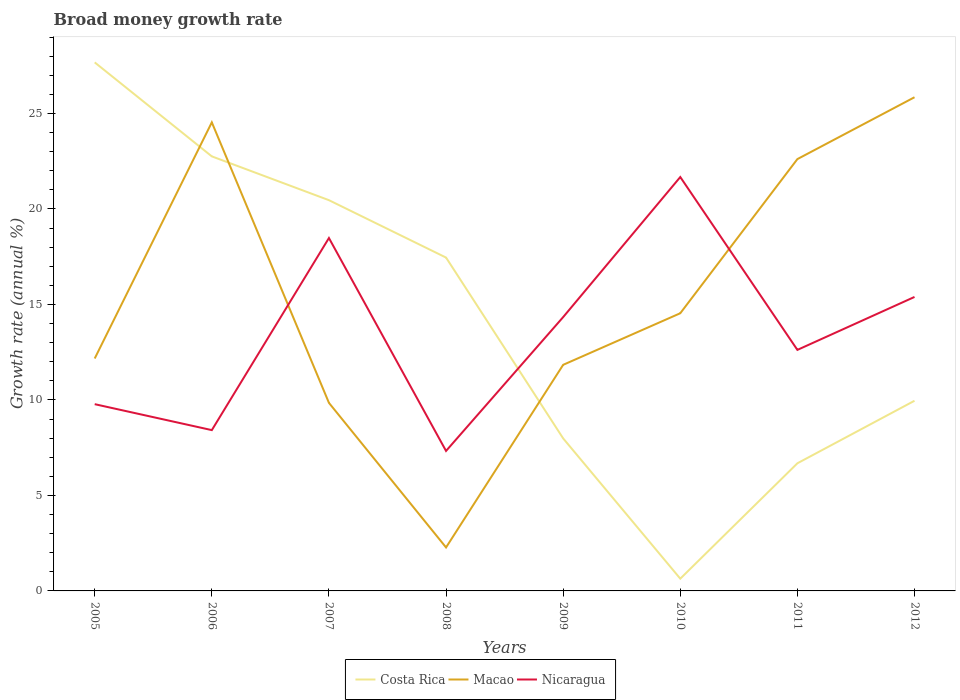How many different coloured lines are there?
Your answer should be compact. 3. Does the line corresponding to Nicaragua intersect with the line corresponding to Costa Rica?
Your answer should be very brief. Yes. Is the number of lines equal to the number of legend labels?
Keep it short and to the point. Yes. Across all years, what is the maximum growth rate in Macao?
Make the answer very short. 2.28. What is the total growth rate in Nicaragua in the graph?
Keep it short and to the point. -8.06. What is the difference between the highest and the second highest growth rate in Nicaragua?
Offer a terse response. 14.34. What is the difference between the highest and the lowest growth rate in Nicaragua?
Ensure brevity in your answer.  4. Is the growth rate in Macao strictly greater than the growth rate in Costa Rica over the years?
Your response must be concise. No. How many years are there in the graph?
Give a very brief answer. 8. What is the difference between two consecutive major ticks on the Y-axis?
Provide a short and direct response. 5. Are the values on the major ticks of Y-axis written in scientific E-notation?
Give a very brief answer. No. Where does the legend appear in the graph?
Your answer should be compact. Bottom center. What is the title of the graph?
Give a very brief answer. Broad money growth rate. Does "Belgium" appear as one of the legend labels in the graph?
Keep it short and to the point. No. What is the label or title of the Y-axis?
Offer a terse response. Growth rate (annual %). What is the Growth rate (annual %) of Costa Rica in 2005?
Provide a succinct answer. 27.68. What is the Growth rate (annual %) in Macao in 2005?
Your response must be concise. 12.17. What is the Growth rate (annual %) in Nicaragua in 2005?
Give a very brief answer. 9.78. What is the Growth rate (annual %) of Costa Rica in 2006?
Provide a short and direct response. 22.76. What is the Growth rate (annual %) in Macao in 2006?
Your answer should be compact. 24.54. What is the Growth rate (annual %) of Nicaragua in 2006?
Your response must be concise. 8.42. What is the Growth rate (annual %) of Costa Rica in 2007?
Provide a short and direct response. 20.46. What is the Growth rate (annual %) in Macao in 2007?
Your response must be concise. 9.85. What is the Growth rate (annual %) of Nicaragua in 2007?
Provide a short and direct response. 18.48. What is the Growth rate (annual %) of Costa Rica in 2008?
Offer a very short reply. 17.46. What is the Growth rate (annual %) in Macao in 2008?
Your answer should be very brief. 2.28. What is the Growth rate (annual %) in Nicaragua in 2008?
Make the answer very short. 7.33. What is the Growth rate (annual %) in Costa Rica in 2009?
Offer a terse response. 7.99. What is the Growth rate (annual %) of Macao in 2009?
Ensure brevity in your answer.  11.84. What is the Growth rate (annual %) of Nicaragua in 2009?
Ensure brevity in your answer.  14.34. What is the Growth rate (annual %) of Costa Rica in 2010?
Your answer should be compact. 0.64. What is the Growth rate (annual %) in Macao in 2010?
Offer a terse response. 14.54. What is the Growth rate (annual %) in Nicaragua in 2010?
Provide a succinct answer. 21.67. What is the Growth rate (annual %) of Costa Rica in 2011?
Offer a very short reply. 6.68. What is the Growth rate (annual %) of Macao in 2011?
Provide a succinct answer. 22.61. What is the Growth rate (annual %) in Nicaragua in 2011?
Keep it short and to the point. 12.62. What is the Growth rate (annual %) in Costa Rica in 2012?
Provide a short and direct response. 9.96. What is the Growth rate (annual %) in Macao in 2012?
Give a very brief answer. 25.85. What is the Growth rate (annual %) of Nicaragua in 2012?
Give a very brief answer. 15.39. Across all years, what is the maximum Growth rate (annual %) of Costa Rica?
Provide a short and direct response. 27.68. Across all years, what is the maximum Growth rate (annual %) of Macao?
Make the answer very short. 25.85. Across all years, what is the maximum Growth rate (annual %) of Nicaragua?
Your answer should be very brief. 21.67. Across all years, what is the minimum Growth rate (annual %) of Costa Rica?
Keep it short and to the point. 0.64. Across all years, what is the minimum Growth rate (annual %) in Macao?
Keep it short and to the point. 2.28. Across all years, what is the minimum Growth rate (annual %) of Nicaragua?
Your answer should be very brief. 7.33. What is the total Growth rate (annual %) in Costa Rica in the graph?
Your response must be concise. 113.62. What is the total Growth rate (annual %) of Macao in the graph?
Your answer should be compact. 123.68. What is the total Growth rate (annual %) in Nicaragua in the graph?
Provide a succinct answer. 108.04. What is the difference between the Growth rate (annual %) in Costa Rica in 2005 and that in 2006?
Offer a very short reply. 4.92. What is the difference between the Growth rate (annual %) in Macao in 2005 and that in 2006?
Your answer should be very brief. -12.37. What is the difference between the Growth rate (annual %) in Nicaragua in 2005 and that in 2006?
Your answer should be compact. 1.36. What is the difference between the Growth rate (annual %) of Costa Rica in 2005 and that in 2007?
Provide a succinct answer. 7.21. What is the difference between the Growth rate (annual %) of Macao in 2005 and that in 2007?
Your response must be concise. 2.32. What is the difference between the Growth rate (annual %) of Nicaragua in 2005 and that in 2007?
Your answer should be compact. -8.7. What is the difference between the Growth rate (annual %) of Costa Rica in 2005 and that in 2008?
Your response must be concise. 10.22. What is the difference between the Growth rate (annual %) in Macao in 2005 and that in 2008?
Keep it short and to the point. 9.89. What is the difference between the Growth rate (annual %) in Nicaragua in 2005 and that in 2008?
Keep it short and to the point. 2.45. What is the difference between the Growth rate (annual %) of Costa Rica in 2005 and that in 2009?
Provide a succinct answer. 19.69. What is the difference between the Growth rate (annual %) in Macao in 2005 and that in 2009?
Your answer should be very brief. 0.33. What is the difference between the Growth rate (annual %) in Nicaragua in 2005 and that in 2009?
Make the answer very short. -4.56. What is the difference between the Growth rate (annual %) in Costa Rica in 2005 and that in 2010?
Your answer should be compact. 27.04. What is the difference between the Growth rate (annual %) of Macao in 2005 and that in 2010?
Provide a short and direct response. -2.37. What is the difference between the Growth rate (annual %) in Nicaragua in 2005 and that in 2010?
Keep it short and to the point. -11.89. What is the difference between the Growth rate (annual %) in Costa Rica in 2005 and that in 2011?
Offer a very short reply. 20.99. What is the difference between the Growth rate (annual %) in Macao in 2005 and that in 2011?
Ensure brevity in your answer.  -10.44. What is the difference between the Growth rate (annual %) in Nicaragua in 2005 and that in 2011?
Make the answer very short. -2.84. What is the difference between the Growth rate (annual %) of Costa Rica in 2005 and that in 2012?
Your answer should be compact. 17.72. What is the difference between the Growth rate (annual %) of Macao in 2005 and that in 2012?
Keep it short and to the point. -13.68. What is the difference between the Growth rate (annual %) in Nicaragua in 2005 and that in 2012?
Your answer should be very brief. -5.61. What is the difference between the Growth rate (annual %) of Costa Rica in 2006 and that in 2007?
Your answer should be very brief. 2.29. What is the difference between the Growth rate (annual %) of Macao in 2006 and that in 2007?
Your answer should be very brief. 14.69. What is the difference between the Growth rate (annual %) in Nicaragua in 2006 and that in 2007?
Offer a very short reply. -10.06. What is the difference between the Growth rate (annual %) in Costa Rica in 2006 and that in 2008?
Keep it short and to the point. 5.3. What is the difference between the Growth rate (annual %) of Macao in 2006 and that in 2008?
Your response must be concise. 22.26. What is the difference between the Growth rate (annual %) of Nicaragua in 2006 and that in 2008?
Make the answer very short. 1.09. What is the difference between the Growth rate (annual %) of Costa Rica in 2006 and that in 2009?
Offer a very short reply. 14.77. What is the difference between the Growth rate (annual %) of Macao in 2006 and that in 2009?
Keep it short and to the point. 12.7. What is the difference between the Growth rate (annual %) in Nicaragua in 2006 and that in 2009?
Provide a short and direct response. -5.92. What is the difference between the Growth rate (annual %) in Costa Rica in 2006 and that in 2010?
Provide a short and direct response. 22.11. What is the difference between the Growth rate (annual %) in Macao in 2006 and that in 2010?
Offer a terse response. 10. What is the difference between the Growth rate (annual %) in Nicaragua in 2006 and that in 2010?
Provide a short and direct response. -13.25. What is the difference between the Growth rate (annual %) of Costa Rica in 2006 and that in 2011?
Make the answer very short. 16.07. What is the difference between the Growth rate (annual %) in Macao in 2006 and that in 2011?
Your response must be concise. 1.92. What is the difference between the Growth rate (annual %) of Nicaragua in 2006 and that in 2011?
Offer a very short reply. -4.2. What is the difference between the Growth rate (annual %) of Costa Rica in 2006 and that in 2012?
Offer a very short reply. 12.8. What is the difference between the Growth rate (annual %) of Macao in 2006 and that in 2012?
Offer a terse response. -1.31. What is the difference between the Growth rate (annual %) in Nicaragua in 2006 and that in 2012?
Offer a terse response. -6.97. What is the difference between the Growth rate (annual %) in Costa Rica in 2007 and that in 2008?
Keep it short and to the point. 3.01. What is the difference between the Growth rate (annual %) in Macao in 2007 and that in 2008?
Your answer should be compact. 7.57. What is the difference between the Growth rate (annual %) of Nicaragua in 2007 and that in 2008?
Your response must be concise. 11.15. What is the difference between the Growth rate (annual %) of Costa Rica in 2007 and that in 2009?
Offer a very short reply. 12.47. What is the difference between the Growth rate (annual %) in Macao in 2007 and that in 2009?
Provide a short and direct response. -1.99. What is the difference between the Growth rate (annual %) of Nicaragua in 2007 and that in 2009?
Keep it short and to the point. 4.14. What is the difference between the Growth rate (annual %) of Costa Rica in 2007 and that in 2010?
Make the answer very short. 19.82. What is the difference between the Growth rate (annual %) in Macao in 2007 and that in 2010?
Your answer should be compact. -4.69. What is the difference between the Growth rate (annual %) of Nicaragua in 2007 and that in 2010?
Provide a succinct answer. -3.19. What is the difference between the Growth rate (annual %) of Costa Rica in 2007 and that in 2011?
Provide a short and direct response. 13.78. What is the difference between the Growth rate (annual %) of Macao in 2007 and that in 2011?
Your answer should be very brief. -12.76. What is the difference between the Growth rate (annual %) of Nicaragua in 2007 and that in 2011?
Keep it short and to the point. 5.86. What is the difference between the Growth rate (annual %) of Costa Rica in 2007 and that in 2012?
Provide a short and direct response. 10.5. What is the difference between the Growth rate (annual %) of Macao in 2007 and that in 2012?
Provide a succinct answer. -16. What is the difference between the Growth rate (annual %) in Nicaragua in 2007 and that in 2012?
Offer a very short reply. 3.09. What is the difference between the Growth rate (annual %) in Costa Rica in 2008 and that in 2009?
Your response must be concise. 9.47. What is the difference between the Growth rate (annual %) of Macao in 2008 and that in 2009?
Make the answer very short. -9.56. What is the difference between the Growth rate (annual %) of Nicaragua in 2008 and that in 2009?
Provide a succinct answer. -7.01. What is the difference between the Growth rate (annual %) of Costa Rica in 2008 and that in 2010?
Provide a short and direct response. 16.81. What is the difference between the Growth rate (annual %) in Macao in 2008 and that in 2010?
Keep it short and to the point. -12.26. What is the difference between the Growth rate (annual %) of Nicaragua in 2008 and that in 2010?
Offer a very short reply. -14.34. What is the difference between the Growth rate (annual %) in Costa Rica in 2008 and that in 2011?
Offer a very short reply. 10.77. What is the difference between the Growth rate (annual %) of Macao in 2008 and that in 2011?
Your answer should be compact. -20.34. What is the difference between the Growth rate (annual %) in Nicaragua in 2008 and that in 2011?
Your response must be concise. -5.29. What is the difference between the Growth rate (annual %) of Costa Rica in 2008 and that in 2012?
Provide a succinct answer. 7.5. What is the difference between the Growth rate (annual %) of Macao in 2008 and that in 2012?
Provide a short and direct response. -23.57. What is the difference between the Growth rate (annual %) in Nicaragua in 2008 and that in 2012?
Your response must be concise. -8.06. What is the difference between the Growth rate (annual %) of Costa Rica in 2009 and that in 2010?
Provide a short and direct response. 7.35. What is the difference between the Growth rate (annual %) of Macao in 2009 and that in 2010?
Your response must be concise. -2.7. What is the difference between the Growth rate (annual %) in Nicaragua in 2009 and that in 2010?
Make the answer very short. -7.33. What is the difference between the Growth rate (annual %) in Costa Rica in 2009 and that in 2011?
Make the answer very short. 1.3. What is the difference between the Growth rate (annual %) of Macao in 2009 and that in 2011?
Keep it short and to the point. -10.77. What is the difference between the Growth rate (annual %) of Nicaragua in 2009 and that in 2011?
Give a very brief answer. 1.72. What is the difference between the Growth rate (annual %) of Costa Rica in 2009 and that in 2012?
Keep it short and to the point. -1.97. What is the difference between the Growth rate (annual %) in Macao in 2009 and that in 2012?
Ensure brevity in your answer.  -14.01. What is the difference between the Growth rate (annual %) in Nicaragua in 2009 and that in 2012?
Offer a very short reply. -1.05. What is the difference between the Growth rate (annual %) in Costa Rica in 2010 and that in 2011?
Offer a very short reply. -6.04. What is the difference between the Growth rate (annual %) of Macao in 2010 and that in 2011?
Make the answer very short. -8.07. What is the difference between the Growth rate (annual %) of Nicaragua in 2010 and that in 2011?
Offer a very short reply. 9.05. What is the difference between the Growth rate (annual %) of Costa Rica in 2010 and that in 2012?
Make the answer very short. -9.32. What is the difference between the Growth rate (annual %) of Macao in 2010 and that in 2012?
Keep it short and to the point. -11.31. What is the difference between the Growth rate (annual %) in Nicaragua in 2010 and that in 2012?
Make the answer very short. 6.28. What is the difference between the Growth rate (annual %) in Costa Rica in 2011 and that in 2012?
Offer a terse response. -3.27. What is the difference between the Growth rate (annual %) in Macao in 2011 and that in 2012?
Provide a short and direct response. -3.24. What is the difference between the Growth rate (annual %) in Nicaragua in 2011 and that in 2012?
Provide a short and direct response. -2.77. What is the difference between the Growth rate (annual %) of Costa Rica in 2005 and the Growth rate (annual %) of Macao in 2006?
Keep it short and to the point. 3.14. What is the difference between the Growth rate (annual %) in Costa Rica in 2005 and the Growth rate (annual %) in Nicaragua in 2006?
Your answer should be compact. 19.26. What is the difference between the Growth rate (annual %) in Macao in 2005 and the Growth rate (annual %) in Nicaragua in 2006?
Keep it short and to the point. 3.75. What is the difference between the Growth rate (annual %) in Costa Rica in 2005 and the Growth rate (annual %) in Macao in 2007?
Your answer should be compact. 17.83. What is the difference between the Growth rate (annual %) of Costa Rica in 2005 and the Growth rate (annual %) of Nicaragua in 2007?
Provide a short and direct response. 9.2. What is the difference between the Growth rate (annual %) of Macao in 2005 and the Growth rate (annual %) of Nicaragua in 2007?
Provide a short and direct response. -6.31. What is the difference between the Growth rate (annual %) in Costa Rica in 2005 and the Growth rate (annual %) in Macao in 2008?
Keep it short and to the point. 25.4. What is the difference between the Growth rate (annual %) of Costa Rica in 2005 and the Growth rate (annual %) of Nicaragua in 2008?
Provide a short and direct response. 20.35. What is the difference between the Growth rate (annual %) in Macao in 2005 and the Growth rate (annual %) in Nicaragua in 2008?
Offer a terse response. 4.84. What is the difference between the Growth rate (annual %) of Costa Rica in 2005 and the Growth rate (annual %) of Macao in 2009?
Your response must be concise. 15.84. What is the difference between the Growth rate (annual %) in Costa Rica in 2005 and the Growth rate (annual %) in Nicaragua in 2009?
Give a very brief answer. 13.34. What is the difference between the Growth rate (annual %) of Macao in 2005 and the Growth rate (annual %) of Nicaragua in 2009?
Give a very brief answer. -2.17. What is the difference between the Growth rate (annual %) in Costa Rica in 2005 and the Growth rate (annual %) in Macao in 2010?
Give a very brief answer. 13.14. What is the difference between the Growth rate (annual %) of Costa Rica in 2005 and the Growth rate (annual %) of Nicaragua in 2010?
Make the answer very short. 6. What is the difference between the Growth rate (annual %) of Macao in 2005 and the Growth rate (annual %) of Nicaragua in 2010?
Provide a succinct answer. -9.5. What is the difference between the Growth rate (annual %) of Costa Rica in 2005 and the Growth rate (annual %) of Macao in 2011?
Offer a terse response. 5.06. What is the difference between the Growth rate (annual %) of Costa Rica in 2005 and the Growth rate (annual %) of Nicaragua in 2011?
Make the answer very short. 15.05. What is the difference between the Growth rate (annual %) of Macao in 2005 and the Growth rate (annual %) of Nicaragua in 2011?
Offer a terse response. -0.45. What is the difference between the Growth rate (annual %) of Costa Rica in 2005 and the Growth rate (annual %) of Macao in 2012?
Provide a succinct answer. 1.82. What is the difference between the Growth rate (annual %) of Costa Rica in 2005 and the Growth rate (annual %) of Nicaragua in 2012?
Offer a very short reply. 12.28. What is the difference between the Growth rate (annual %) of Macao in 2005 and the Growth rate (annual %) of Nicaragua in 2012?
Your answer should be very brief. -3.22. What is the difference between the Growth rate (annual %) of Costa Rica in 2006 and the Growth rate (annual %) of Macao in 2007?
Offer a very short reply. 12.91. What is the difference between the Growth rate (annual %) in Costa Rica in 2006 and the Growth rate (annual %) in Nicaragua in 2007?
Ensure brevity in your answer.  4.28. What is the difference between the Growth rate (annual %) of Macao in 2006 and the Growth rate (annual %) of Nicaragua in 2007?
Keep it short and to the point. 6.06. What is the difference between the Growth rate (annual %) of Costa Rica in 2006 and the Growth rate (annual %) of Macao in 2008?
Your response must be concise. 20.48. What is the difference between the Growth rate (annual %) in Costa Rica in 2006 and the Growth rate (annual %) in Nicaragua in 2008?
Offer a very short reply. 15.43. What is the difference between the Growth rate (annual %) of Macao in 2006 and the Growth rate (annual %) of Nicaragua in 2008?
Offer a very short reply. 17.21. What is the difference between the Growth rate (annual %) in Costa Rica in 2006 and the Growth rate (annual %) in Macao in 2009?
Your answer should be compact. 10.92. What is the difference between the Growth rate (annual %) of Costa Rica in 2006 and the Growth rate (annual %) of Nicaragua in 2009?
Ensure brevity in your answer.  8.42. What is the difference between the Growth rate (annual %) of Macao in 2006 and the Growth rate (annual %) of Nicaragua in 2009?
Make the answer very short. 10.2. What is the difference between the Growth rate (annual %) in Costa Rica in 2006 and the Growth rate (annual %) in Macao in 2010?
Provide a succinct answer. 8.21. What is the difference between the Growth rate (annual %) of Costa Rica in 2006 and the Growth rate (annual %) of Nicaragua in 2010?
Ensure brevity in your answer.  1.08. What is the difference between the Growth rate (annual %) of Macao in 2006 and the Growth rate (annual %) of Nicaragua in 2010?
Make the answer very short. 2.86. What is the difference between the Growth rate (annual %) in Costa Rica in 2006 and the Growth rate (annual %) in Macao in 2011?
Ensure brevity in your answer.  0.14. What is the difference between the Growth rate (annual %) of Costa Rica in 2006 and the Growth rate (annual %) of Nicaragua in 2011?
Provide a short and direct response. 10.13. What is the difference between the Growth rate (annual %) of Macao in 2006 and the Growth rate (annual %) of Nicaragua in 2011?
Offer a very short reply. 11.92. What is the difference between the Growth rate (annual %) in Costa Rica in 2006 and the Growth rate (annual %) in Macao in 2012?
Keep it short and to the point. -3.1. What is the difference between the Growth rate (annual %) in Costa Rica in 2006 and the Growth rate (annual %) in Nicaragua in 2012?
Your response must be concise. 7.36. What is the difference between the Growth rate (annual %) of Macao in 2006 and the Growth rate (annual %) of Nicaragua in 2012?
Keep it short and to the point. 9.14. What is the difference between the Growth rate (annual %) in Costa Rica in 2007 and the Growth rate (annual %) in Macao in 2008?
Offer a terse response. 18.18. What is the difference between the Growth rate (annual %) of Costa Rica in 2007 and the Growth rate (annual %) of Nicaragua in 2008?
Give a very brief answer. 13.13. What is the difference between the Growth rate (annual %) in Macao in 2007 and the Growth rate (annual %) in Nicaragua in 2008?
Ensure brevity in your answer.  2.52. What is the difference between the Growth rate (annual %) of Costa Rica in 2007 and the Growth rate (annual %) of Macao in 2009?
Your answer should be very brief. 8.62. What is the difference between the Growth rate (annual %) in Costa Rica in 2007 and the Growth rate (annual %) in Nicaragua in 2009?
Offer a very short reply. 6.12. What is the difference between the Growth rate (annual %) in Macao in 2007 and the Growth rate (annual %) in Nicaragua in 2009?
Your answer should be compact. -4.49. What is the difference between the Growth rate (annual %) of Costa Rica in 2007 and the Growth rate (annual %) of Macao in 2010?
Provide a succinct answer. 5.92. What is the difference between the Growth rate (annual %) in Costa Rica in 2007 and the Growth rate (annual %) in Nicaragua in 2010?
Your answer should be very brief. -1.21. What is the difference between the Growth rate (annual %) in Macao in 2007 and the Growth rate (annual %) in Nicaragua in 2010?
Ensure brevity in your answer.  -11.83. What is the difference between the Growth rate (annual %) in Costa Rica in 2007 and the Growth rate (annual %) in Macao in 2011?
Your answer should be compact. -2.15. What is the difference between the Growth rate (annual %) of Costa Rica in 2007 and the Growth rate (annual %) of Nicaragua in 2011?
Your answer should be very brief. 7.84. What is the difference between the Growth rate (annual %) in Macao in 2007 and the Growth rate (annual %) in Nicaragua in 2011?
Your answer should be compact. -2.77. What is the difference between the Growth rate (annual %) of Costa Rica in 2007 and the Growth rate (annual %) of Macao in 2012?
Your answer should be very brief. -5.39. What is the difference between the Growth rate (annual %) in Costa Rica in 2007 and the Growth rate (annual %) in Nicaragua in 2012?
Ensure brevity in your answer.  5.07. What is the difference between the Growth rate (annual %) in Macao in 2007 and the Growth rate (annual %) in Nicaragua in 2012?
Your response must be concise. -5.55. What is the difference between the Growth rate (annual %) of Costa Rica in 2008 and the Growth rate (annual %) of Macao in 2009?
Make the answer very short. 5.62. What is the difference between the Growth rate (annual %) in Costa Rica in 2008 and the Growth rate (annual %) in Nicaragua in 2009?
Provide a short and direct response. 3.12. What is the difference between the Growth rate (annual %) of Macao in 2008 and the Growth rate (annual %) of Nicaragua in 2009?
Offer a very short reply. -12.06. What is the difference between the Growth rate (annual %) in Costa Rica in 2008 and the Growth rate (annual %) in Macao in 2010?
Keep it short and to the point. 2.92. What is the difference between the Growth rate (annual %) of Costa Rica in 2008 and the Growth rate (annual %) of Nicaragua in 2010?
Make the answer very short. -4.22. What is the difference between the Growth rate (annual %) of Macao in 2008 and the Growth rate (annual %) of Nicaragua in 2010?
Provide a succinct answer. -19.4. What is the difference between the Growth rate (annual %) in Costa Rica in 2008 and the Growth rate (annual %) in Macao in 2011?
Your answer should be very brief. -5.16. What is the difference between the Growth rate (annual %) of Costa Rica in 2008 and the Growth rate (annual %) of Nicaragua in 2011?
Offer a terse response. 4.83. What is the difference between the Growth rate (annual %) in Macao in 2008 and the Growth rate (annual %) in Nicaragua in 2011?
Offer a very short reply. -10.35. What is the difference between the Growth rate (annual %) in Costa Rica in 2008 and the Growth rate (annual %) in Macao in 2012?
Your response must be concise. -8.4. What is the difference between the Growth rate (annual %) of Costa Rica in 2008 and the Growth rate (annual %) of Nicaragua in 2012?
Your response must be concise. 2.06. What is the difference between the Growth rate (annual %) in Macao in 2008 and the Growth rate (annual %) in Nicaragua in 2012?
Keep it short and to the point. -13.12. What is the difference between the Growth rate (annual %) of Costa Rica in 2009 and the Growth rate (annual %) of Macao in 2010?
Provide a short and direct response. -6.55. What is the difference between the Growth rate (annual %) in Costa Rica in 2009 and the Growth rate (annual %) in Nicaragua in 2010?
Offer a terse response. -13.69. What is the difference between the Growth rate (annual %) of Macao in 2009 and the Growth rate (annual %) of Nicaragua in 2010?
Give a very brief answer. -9.83. What is the difference between the Growth rate (annual %) of Costa Rica in 2009 and the Growth rate (annual %) of Macao in 2011?
Make the answer very short. -14.63. What is the difference between the Growth rate (annual %) in Costa Rica in 2009 and the Growth rate (annual %) in Nicaragua in 2011?
Keep it short and to the point. -4.63. What is the difference between the Growth rate (annual %) in Macao in 2009 and the Growth rate (annual %) in Nicaragua in 2011?
Make the answer very short. -0.78. What is the difference between the Growth rate (annual %) in Costa Rica in 2009 and the Growth rate (annual %) in Macao in 2012?
Your response must be concise. -17.86. What is the difference between the Growth rate (annual %) in Costa Rica in 2009 and the Growth rate (annual %) in Nicaragua in 2012?
Offer a terse response. -7.41. What is the difference between the Growth rate (annual %) in Macao in 2009 and the Growth rate (annual %) in Nicaragua in 2012?
Your answer should be compact. -3.55. What is the difference between the Growth rate (annual %) in Costa Rica in 2010 and the Growth rate (annual %) in Macao in 2011?
Keep it short and to the point. -21.97. What is the difference between the Growth rate (annual %) of Costa Rica in 2010 and the Growth rate (annual %) of Nicaragua in 2011?
Give a very brief answer. -11.98. What is the difference between the Growth rate (annual %) in Macao in 2010 and the Growth rate (annual %) in Nicaragua in 2011?
Ensure brevity in your answer.  1.92. What is the difference between the Growth rate (annual %) of Costa Rica in 2010 and the Growth rate (annual %) of Macao in 2012?
Your answer should be compact. -25.21. What is the difference between the Growth rate (annual %) of Costa Rica in 2010 and the Growth rate (annual %) of Nicaragua in 2012?
Your response must be concise. -14.75. What is the difference between the Growth rate (annual %) of Macao in 2010 and the Growth rate (annual %) of Nicaragua in 2012?
Offer a very short reply. -0.85. What is the difference between the Growth rate (annual %) in Costa Rica in 2011 and the Growth rate (annual %) in Macao in 2012?
Offer a terse response. -19.17. What is the difference between the Growth rate (annual %) in Costa Rica in 2011 and the Growth rate (annual %) in Nicaragua in 2012?
Offer a terse response. -8.71. What is the difference between the Growth rate (annual %) in Macao in 2011 and the Growth rate (annual %) in Nicaragua in 2012?
Offer a very short reply. 7.22. What is the average Growth rate (annual %) in Costa Rica per year?
Provide a succinct answer. 14.2. What is the average Growth rate (annual %) in Macao per year?
Provide a short and direct response. 15.46. What is the average Growth rate (annual %) in Nicaragua per year?
Offer a very short reply. 13.5. In the year 2005, what is the difference between the Growth rate (annual %) in Costa Rica and Growth rate (annual %) in Macao?
Make the answer very short. 15.51. In the year 2005, what is the difference between the Growth rate (annual %) in Costa Rica and Growth rate (annual %) in Nicaragua?
Make the answer very short. 17.9. In the year 2005, what is the difference between the Growth rate (annual %) in Macao and Growth rate (annual %) in Nicaragua?
Make the answer very short. 2.39. In the year 2006, what is the difference between the Growth rate (annual %) in Costa Rica and Growth rate (annual %) in Macao?
Make the answer very short. -1.78. In the year 2006, what is the difference between the Growth rate (annual %) in Costa Rica and Growth rate (annual %) in Nicaragua?
Provide a succinct answer. 14.34. In the year 2006, what is the difference between the Growth rate (annual %) in Macao and Growth rate (annual %) in Nicaragua?
Provide a short and direct response. 16.12. In the year 2007, what is the difference between the Growth rate (annual %) in Costa Rica and Growth rate (annual %) in Macao?
Your answer should be compact. 10.61. In the year 2007, what is the difference between the Growth rate (annual %) of Costa Rica and Growth rate (annual %) of Nicaragua?
Your answer should be compact. 1.98. In the year 2007, what is the difference between the Growth rate (annual %) in Macao and Growth rate (annual %) in Nicaragua?
Offer a terse response. -8.63. In the year 2008, what is the difference between the Growth rate (annual %) of Costa Rica and Growth rate (annual %) of Macao?
Make the answer very short. 15.18. In the year 2008, what is the difference between the Growth rate (annual %) in Costa Rica and Growth rate (annual %) in Nicaragua?
Offer a terse response. 10.13. In the year 2008, what is the difference between the Growth rate (annual %) of Macao and Growth rate (annual %) of Nicaragua?
Give a very brief answer. -5.05. In the year 2009, what is the difference between the Growth rate (annual %) in Costa Rica and Growth rate (annual %) in Macao?
Make the answer very short. -3.85. In the year 2009, what is the difference between the Growth rate (annual %) in Costa Rica and Growth rate (annual %) in Nicaragua?
Offer a very short reply. -6.35. In the year 2009, what is the difference between the Growth rate (annual %) in Macao and Growth rate (annual %) in Nicaragua?
Give a very brief answer. -2.5. In the year 2010, what is the difference between the Growth rate (annual %) in Costa Rica and Growth rate (annual %) in Macao?
Provide a short and direct response. -13.9. In the year 2010, what is the difference between the Growth rate (annual %) of Costa Rica and Growth rate (annual %) of Nicaragua?
Keep it short and to the point. -21.03. In the year 2010, what is the difference between the Growth rate (annual %) of Macao and Growth rate (annual %) of Nicaragua?
Offer a very short reply. -7.13. In the year 2011, what is the difference between the Growth rate (annual %) in Costa Rica and Growth rate (annual %) in Macao?
Keep it short and to the point. -15.93. In the year 2011, what is the difference between the Growth rate (annual %) of Costa Rica and Growth rate (annual %) of Nicaragua?
Your response must be concise. -5.94. In the year 2011, what is the difference between the Growth rate (annual %) of Macao and Growth rate (annual %) of Nicaragua?
Provide a succinct answer. 9.99. In the year 2012, what is the difference between the Growth rate (annual %) of Costa Rica and Growth rate (annual %) of Macao?
Provide a succinct answer. -15.89. In the year 2012, what is the difference between the Growth rate (annual %) in Costa Rica and Growth rate (annual %) in Nicaragua?
Provide a short and direct response. -5.44. In the year 2012, what is the difference between the Growth rate (annual %) of Macao and Growth rate (annual %) of Nicaragua?
Ensure brevity in your answer.  10.46. What is the ratio of the Growth rate (annual %) of Costa Rica in 2005 to that in 2006?
Offer a very short reply. 1.22. What is the ratio of the Growth rate (annual %) of Macao in 2005 to that in 2006?
Provide a short and direct response. 0.5. What is the ratio of the Growth rate (annual %) in Nicaragua in 2005 to that in 2006?
Provide a short and direct response. 1.16. What is the ratio of the Growth rate (annual %) in Costa Rica in 2005 to that in 2007?
Your answer should be compact. 1.35. What is the ratio of the Growth rate (annual %) in Macao in 2005 to that in 2007?
Your answer should be compact. 1.24. What is the ratio of the Growth rate (annual %) of Nicaragua in 2005 to that in 2007?
Keep it short and to the point. 0.53. What is the ratio of the Growth rate (annual %) of Costa Rica in 2005 to that in 2008?
Give a very brief answer. 1.59. What is the ratio of the Growth rate (annual %) of Macao in 2005 to that in 2008?
Offer a terse response. 5.35. What is the ratio of the Growth rate (annual %) of Nicaragua in 2005 to that in 2008?
Your response must be concise. 1.33. What is the ratio of the Growth rate (annual %) of Costa Rica in 2005 to that in 2009?
Provide a succinct answer. 3.47. What is the ratio of the Growth rate (annual %) of Macao in 2005 to that in 2009?
Give a very brief answer. 1.03. What is the ratio of the Growth rate (annual %) in Nicaragua in 2005 to that in 2009?
Keep it short and to the point. 0.68. What is the ratio of the Growth rate (annual %) in Costa Rica in 2005 to that in 2010?
Make the answer very short. 43.15. What is the ratio of the Growth rate (annual %) of Macao in 2005 to that in 2010?
Your answer should be very brief. 0.84. What is the ratio of the Growth rate (annual %) of Nicaragua in 2005 to that in 2010?
Ensure brevity in your answer.  0.45. What is the ratio of the Growth rate (annual %) of Costa Rica in 2005 to that in 2011?
Your response must be concise. 4.14. What is the ratio of the Growth rate (annual %) of Macao in 2005 to that in 2011?
Your response must be concise. 0.54. What is the ratio of the Growth rate (annual %) in Nicaragua in 2005 to that in 2011?
Offer a terse response. 0.77. What is the ratio of the Growth rate (annual %) of Costa Rica in 2005 to that in 2012?
Give a very brief answer. 2.78. What is the ratio of the Growth rate (annual %) in Macao in 2005 to that in 2012?
Offer a terse response. 0.47. What is the ratio of the Growth rate (annual %) of Nicaragua in 2005 to that in 2012?
Your response must be concise. 0.64. What is the ratio of the Growth rate (annual %) of Costa Rica in 2006 to that in 2007?
Your answer should be very brief. 1.11. What is the ratio of the Growth rate (annual %) of Macao in 2006 to that in 2007?
Your answer should be very brief. 2.49. What is the ratio of the Growth rate (annual %) of Nicaragua in 2006 to that in 2007?
Provide a succinct answer. 0.46. What is the ratio of the Growth rate (annual %) in Costa Rica in 2006 to that in 2008?
Provide a short and direct response. 1.3. What is the ratio of the Growth rate (annual %) in Macao in 2006 to that in 2008?
Ensure brevity in your answer.  10.78. What is the ratio of the Growth rate (annual %) of Nicaragua in 2006 to that in 2008?
Your answer should be compact. 1.15. What is the ratio of the Growth rate (annual %) of Costa Rica in 2006 to that in 2009?
Offer a very short reply. 2.85. What is the ratio of the Growth rate (annual %) of Macao in 2006 to that in 2009?
Offer a terse response. 2.07. What is the ratio of the Growth rate (annual %) of Nicaragua in 2006 to that in 2009?
Give a very brief answer. 0.59. What is the ratio of the Growth rate (annual %) in Costa Rica in 2006 to that in 2010?
Your answer should be compact. 35.48. What is the ratio of the Growth rate (annual %) of Macao in 2006 to that in 2010?
Your answer should be very brief. 1.69. What is the ratio of the Growth rate (annual %) in Nicaragua in 2006 to that in 2010?
Your answer should be compact. 0.39. What is the ratio of the Growth rate (annual %) of Costa Rica in 2006 to that in 2011?
Keep it short and to the point. 3.4. What is the ratio of the Growth rate (annual %) of Macao in 2006 to that in 2011?
Your response must be concise. 1.09. What is the ratio of the Growth rate (annual %) of Nicaragua in 2006 to that in 2011?
Keep it short and to the point. 0.67. What is the ratio of the Growth rate (annual %) in Costa Rica in 2006 to that in 2012?
Offer a terse response. 2.29. What is the ratio of the Growth rate (annual %) of Macao in 2006 to that in 2012?
Make the answer very short. 0.95. What is the ratio of the Growth rate (annual %) of Nicaragua in 2006 to that in 2012?
Your answer should be compact. 0.55. What is the ratio of the Growth rate (annual %) in Costa Rica in 2007 to that in 2008?
Your answer should be very brief. 1.17. What is the ratio of the Growth rate (annual %) in Macao in 2007 to that in 2008?
Give a very brief answer. 4.33. What is the ratio of the Growth rate (annual %) of Nicaragua in 2007 to that in 2008?
Your answer should be compact. 2.52. What is the ratio of the Growth rate (annual %) in Costa Rica in 2007 to that in 2009?
Make the answer very short. 2.56. What is the ratio of the Growth rate (annual %) of Macao in 2007 to that in 2009?
Provide a succinct answer. 0.83. What is the ratio of the Growth rate (annual %) of Nicaragua in 2007 to that in 2009?
Your answer should be very brief. 1.29. What is the ratio of the Growth rate (annual %) of Costa Rica in 2007 to that in 2010?
Offer a very short reply. 31.9. What is the ratio of the Growth rate (annual %) in Macao in 2007 to that in 2010?
Provide a succinct answer. 0.68. What is the ratio of the Growth rate (annual %) in Nicaragua in 2007 to that in 2010?
Make the answer very short. 0.85. What is the ratio of the Growth rate (annual %) in Costa Rica in 2007 to that in 2011?
Ensure brevity in your answer.  3.06. What is the ratio of the Growth rate (annual %) of Macao in 2007 to that in 2011?
Provide a short and direct response. 0.44. What is the ratio of the Growth rate (annual %) in Nicaragua in 2007 to that in 2011?
Your response must be concise. 1.46. What is the ratio of the Growth rate (annual %) in Costa Rica in 2007 to that in 2012?
Your answer should be very brief. 2.05. What is the ratio of the Growth rate (annual %) in Macao in 2007 to that in 2012?
Offer a very short reply. 0.38. What is the ratio of the Growth rate (annual %) of Nicaragua in 2007 to that in 2012?
Your answer should be compact. 1.2. What is the ratio of the Growth rate (annual %) of Costa Rica in 2008 to that in 2009?
Provide a short and direct response. 2.19. What is the ratio of the Growth rate (annual %) of Macao in 2008 to that in 2009?
Provide a short and direct response. 0.19. What is the ratio of the Growth rate (annual %) in Nicaragua in 2008 to that in 2009?
Your answer should be compact. 0.51. What is the ratio of the Growth rate (annual %) of Costa Rica in 2008 to that in 2010?
Your answer should be compact. 27.21. What is the ratio of the Growth rate (annual %) in Macao in 2008 to that in 2010?
Your answer should be very brief. 0.16. What is the ratio of the Growth rate (annual %) in Nicaragua in 2008 to that in 2010?
Give a very brief answer. 0.34. What is the ratio of the Growth rate (annual %) in Costa Rica in 2008 to that in 2011?
Your response must be concise. 2.61. What is the ratio of the Growth rate (annual %) of Macao in 2008 to that in 2011?
Keep it short and to the point. 0.1. What is the ratio of the Growth rate (annual %) in Nicaragua in 2008 to that in 2011?
Make the answer very short. 0.58. What is the ratio of the Growth rate (annual %) of Costa Rica in 2008 to that in 2012?
Offer a terse response. 1.75. What is the ratio of the Growth rate (annual %) of Macao in 2008 to that in 2012?
Your answer should be compact. 0.09. What is the ratio of the Growth rate (annual %) of Nicaragua in 2008 to that in 2012?
Offer a very short reply. 0.48. What is the ratio of the Growth rate (annual %) in Costa Rica in 2009 to that in 2010?
Offer a very short reply. 12.45. What is the ratio of the Growth rate (annual %) of Macao in 2009 to that in 2010?
Ensure brevity in your answer.  0.81. What is the ratio of the Growth rate (annual %) of Nicaragua in 2009 to that in 2010?
Make the answer very short. 0.66. What is the ratio of the Growth rate (annual %) in Costa Rica in 2009 to that in 2011?
Your answer should be compact. 1.2. What is the ratio of the Growth rate (annual %) of Macao in 2009 to that in 2011?
Make the answer very short. 0.52. What is the ratio of the Growth rate (annual %) of Nicaragua in 2009 to that in 2011?
Your answer should be compact. 1.14. What is the ratio of the Growth rate (annual %) of Costa Rica in 2009 to that in 2012?
Provide a short and direct response. 0.8. What is the ratio of the Growth rate (annual %) in Macao in 2009 to that in 2012?
Provide a short and direct response. 0.46. What is the ratio of the Growth rate (annual %) of Nicaragua in 2009 to that in 2012?
Your answer should be compact. 0.93. What is the ratio of the Growth rate (annual %) in Costa Rica in 2010 to that in 2011?
Keep it short and to the point. 0.1. What is the ratio of the Growth rate (annual %) in Macao in 2010 to that in 2011?
Offer a very short reply. 0.64. What is the ratio of the Growth rate (annual %) in Nicaragua in 2010 to that in 2011?
Your answer should be compact. 1.72. What is the ratio of the Growth rate (annual %) in Costa Rica in 2010 to that in 2012?
Ensure brevity in your answer.  0.06. What is the ratio of the Growth rate (annual %) in Macao in 2010 to that in 2012?
Provide a short and direct response. 0.56. What is the ratio of the Growth rate (annual %) of Nicaragua in 2010 to that in 2012?
Offer a very short reply. 1.41. What is the ratio of the Growth rate (annual %) in Costa Rica in 2011 to that in 2012?
Your answer should be compact. 0.67. What is the ratio of the Growth rate (annual %) in Macao in 2011 to that in 2012?
Ensure brevity in your answer.  0.87. What is the ratio of the Growth rate (annual %) of Nicaragua in 2011 to that in 2012?
Make the answer very short. 0.82. What is the difference between the highest and the second highest Growth rate (annual %) of Costa Rica?
Your response must be concise. 4.92. What is the difference between the highest and the second highest Growth rate (annual %) in Macao?
Offer a terse response. 1.31. What is the difference between the highest and the second highest Growth rate (annual %) of Nicaragua?
Your answer should be compact. 3.19. What is the difference between the highest and the lowest Growth rate (annual %) of Costa Rica?
Your answer should be compact. 27.04. What is the difference between the highest and the lowest Growth rate (annual %) of Macao?
Keep it short and to the point. 23.57. What is the difference between the highest and the lowest Growth rate (annual %) in Nicaragua?
Provide a short and direct response. 14.34. 